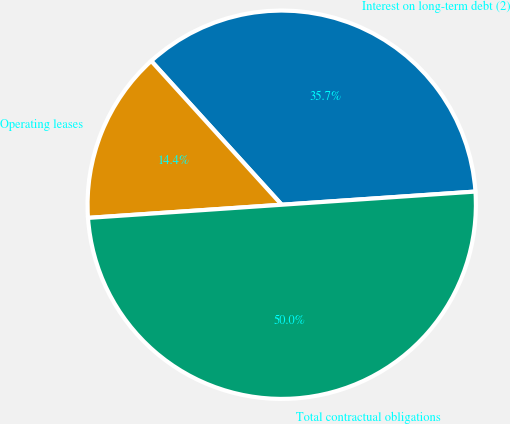Convert chart to OTSL. <chart><loc_0><loc_0><loc_500><loc_500><pie_chart><fcel>Interest on long-term debt (2)<fcel>Operating leases<fcel>Total contractual obligations<nl><fcel>35.65%<fcel>14.35%<fcel>50.0%<nl></chart> 